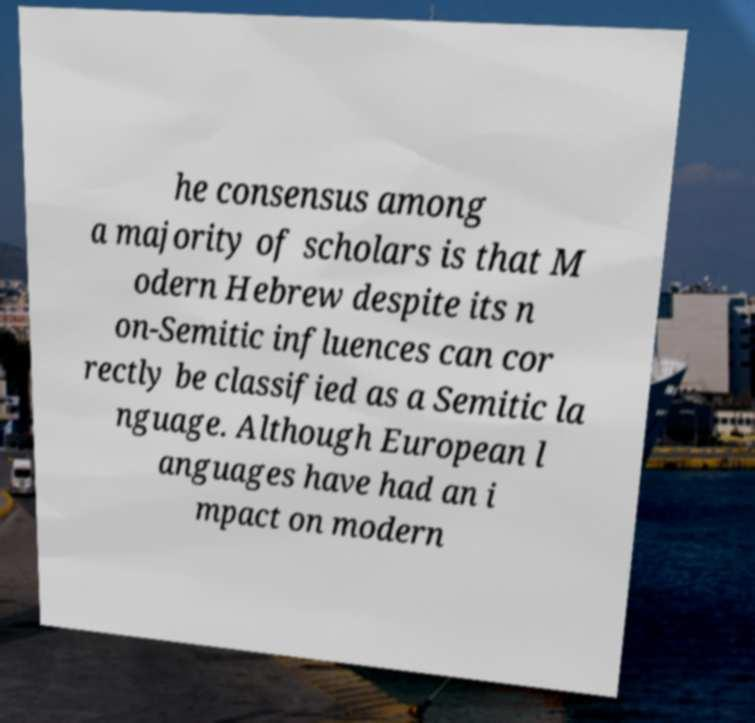What messages or text are displayed in this image? I need them in a readable, typed format. he consensus among a majority of scholars is that M odern Hebrew despite its n on-Semitic influences can cor rectly be classified as a Semitic la nguage. Although European l anguages have had an i mpact on modern 